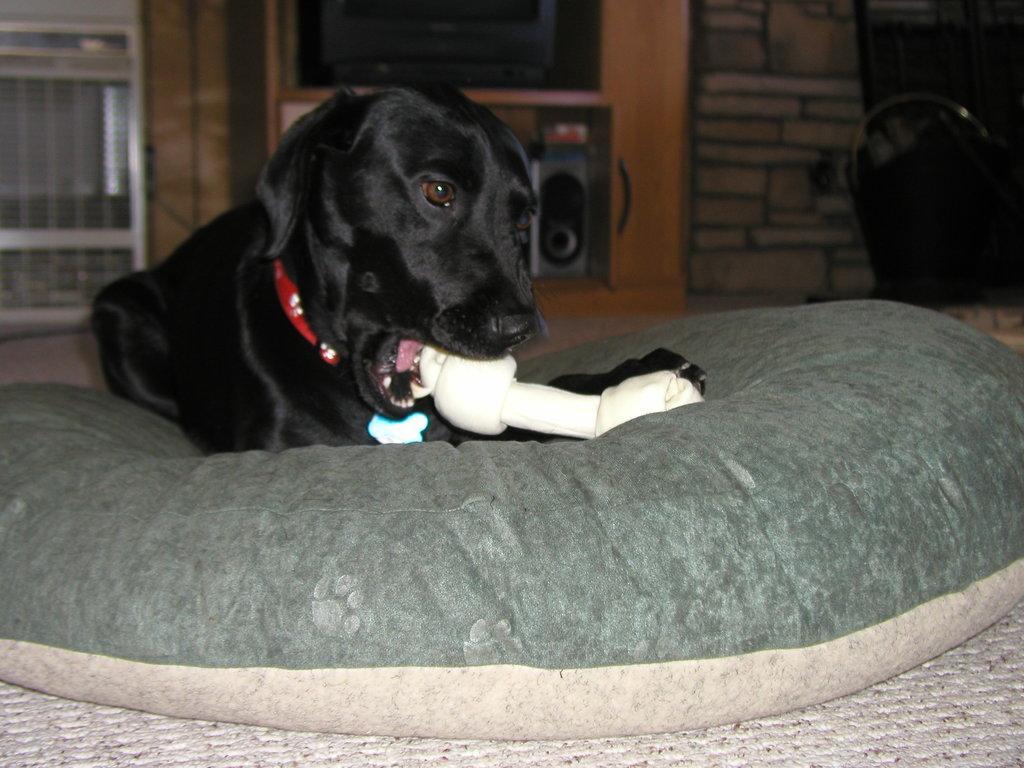In one or two sentences, can you explain what this image depicts? In this image I can see a cushion in the front and on it I can see a black colour dog and a white colour thing. In the background I can see a television, a speaker and few other things. 